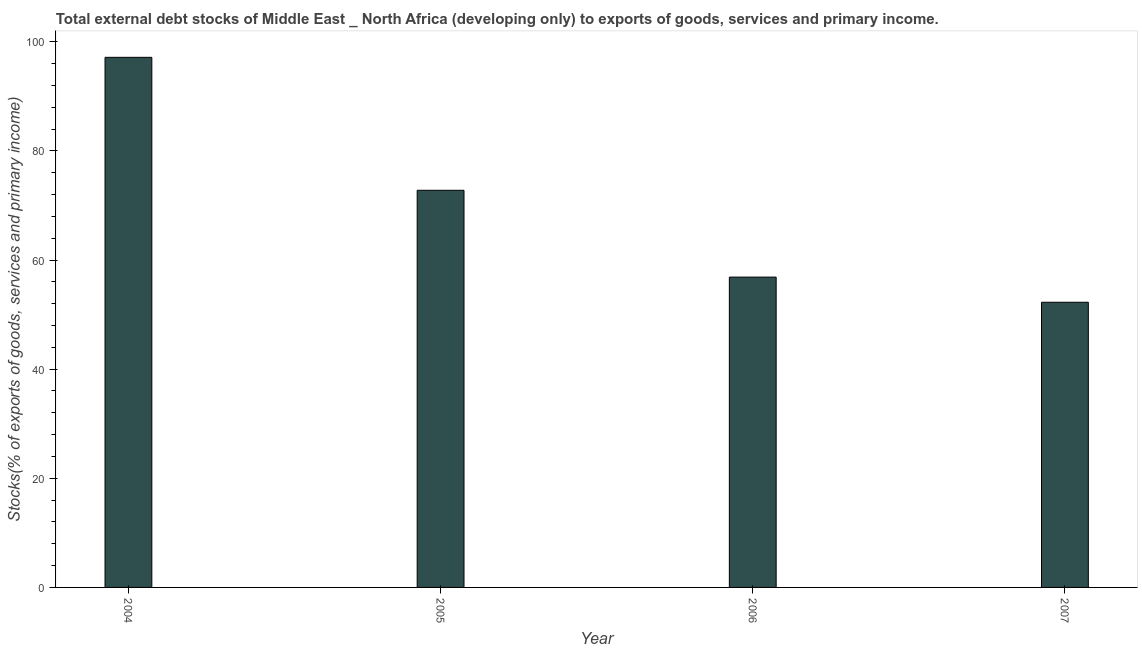Does the graph contain any zero values?
Your response must be concise. No. What is the title of the graph?
Your response must be concise. Total external debt stocks of Middle East _ North Africa (developing only) to exports of goods, services and primary income. What is the label or title of the Y-axis?
Your answer should be compact. Stocks(% of exports of goods, services and primary income). What is the external debt stocks in 2006?
Provide a short and direct response. 56.87. Across all years, what is the maximum external debt stocks?
Offer a very short reply. 97.14. Across all years, what is the minimum external debt stocks?
Your answer should be very brief. 52.26. In which year was the external debt stocks maximum?
Provide a short and direct response. 2004. In which year was the external debt stocks minimum?
Your answer should be very brief. 2007. What is the sum of the external debt stocks?
Ensure brevity in your answer.  279.04. What is the difference between the external debt stocks in 2006 and 2007?
Make the answer very short. 4.61. What is the average external debt stocks per year?
Make the answer very short. 69.76. What is the median external debt stocks?
Ensure brevity in your answer.  64.82. Do a majority of the years between 2004 and 2005 (inclusive) have external debt stocks greater than 52 %?
Keep it short and to the point. Yes. What is the ratio of the external debt stocks in 2004 to that in 2006?
Provide a short and direct response. 1.71. What is the difference between the highest and the second highest external debt stocks?
Offer a very short reply. 24.36. Is the sum of the external debt stocks in 2005 and 2007 greater than the maximum external debt stocks across all years?
Your response must be concise. Yes. What is the difference between the highest and the lowest external debt stocks?
Provide a short and direct response. 44.88. In how many years, is the external debt stocks greater than the average external debt stocks taken over all years?
Make the answer very short. 2. How many bars are there?
Offer a very short reply. 4. How many years are there in the graph?
Give a very brief answer. 4. What is the Stocks(% of exports of goods, services and primary income) of 2004?
Your answer should be compact. 97.14. What is the Stocks(% of exports of goods, services and primary income) of 2005?
Your answer should be very brief. 72.78. What is the Stocks(% of exports of goods, services and primary income) of 2006?
Your answer should be very brief. 56.87. What is the Stocks(% of exports of goods, services and primary income) in 2007?
Provide a short and direct response. 52.26. What is the difference between the Stocks(% of exports of goods, services and primary income) in 2004 and 2005?
Give a very brief answer. 24.36. What is the difference between the Stocks(% of exports of goods, services and primary income) in 2004 and 2006?
Offer a terse response. 40.27. What is the difference between the Stocks(% of exports of goods, services and primary income) in 2004 and 2007?
Offer a terse response. 44.88. What is the difference between the Stocks(% of exports of goods, services and primary income) in 2005 and 2006?
Keep it short and to the point. 15.91. What is the difference between the Stocks(% of exports of goods, services and primary income) in 2005 and 2007?
Provide a short and direct response. 20.52. What is the difference between the Stocks(% of exports of goods, services and primary income) in 2006 and 2007?
Ensure brevity in your answer.  4.61. What is the ratio of the Stocks(% of exports of goods, services and primary income) in 2004 to that in 2005?
Your answer should be compact. 1.33. What is the ratio of the Stocks(% of exports of goods, services and primary income) in 2004 to that in 2006?
Make the answer very short. 1.71. What is the ratio of the Stocks(% of exports of goods, services and primary income) in 2004 to that in 2007?
Keep it short and to the point. 1.86. What is the ratio of the Stocks(% of exports of goods, services and primary income) in 2005 to that in 2006?
Offer a very short reply. 1.28. What is the ratio of the Stocks(% of exports of goods, services and primary income) in 2005 to that in 2007?
Provide a succinct answer. 1.39. What is the ratio of the Stocks(% of exports of goods, services and primary income) in 2006 to that in 2007?
Your answer should be compact. 1.09. 